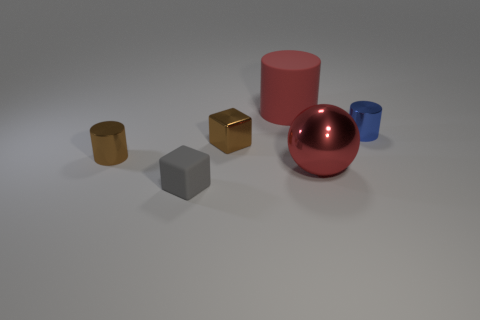What is the color of the cylinder that is the same material as the gray block?
Offer a terse response. Red. Does the brown shiny cylinder have the same size as the matte object behind the small brown cube?
Your response must be concise. No. What is the shape of the large red metallic thing?
Ensure brevity in your answer.  Sphere. How many matte cylinders have the same color as the sphere?
Offer a very short reply. 1. The other small thing that is the same shape as the tiny matte thing is what color?
Provide a succinct answer. Brown. There is a small shiny cylinder that is on the left side of the brown cube; how many big red things are in front of it?
Provide a succinct answer. 1. How many cylinders are gray rubber objects or large red metallic things?
Provide a succinct answer. 0. Are there any tiny blue things?
Ensure brevity in your answer.  Yes. The metal object that is the same shape as the tiny gray matte thing is what size?
Ensure brevity in your answer.  Small. There is a rubber object that is left of the thing behind the blue metal cylinder; what is its shape?
Your answer should be very brief. Cube. 